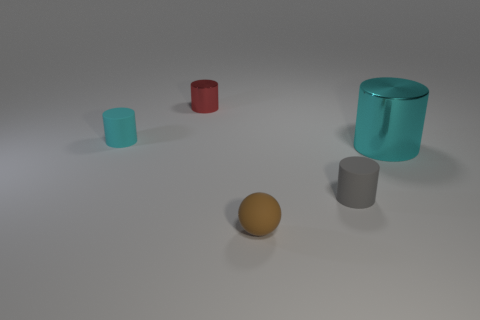There is a small rubber thing that is on the right side of the brown matte thing; what is its shape?
Keep it short and to the point. Cylinder. Is the brown thing made of the same material as the cyan object on the left side of the gray rubber cylinder?
Offer a very short reply. Yes. Are there any big gray rubber balls?
Give a very brief answer. No. Is there a tiny ball that is behind the metallic cylinder that is left of the metallic cylinder that is right of the tiny red metal cylinder?
Make the answer very short. No. How many big objects are gray matte cylinders or spheres?
Your answer should be very brief. 0. What color is the sphere that is the same size as the red cylinder?
Offer a terse response. Brown. There is a tiny shiny cylinder; how many small cyan things are on the right side of it?
Offer a terse response. 0. Is there a large yellow block that has the same material as the red thing?
Your response must be concise. No. The tiny rubber cylinder that is to the right of the small brown rubber object is what color?
Make the answer very short. Gray. Are there the same number of big cyan metal cylinders behind the cyan rubber thing and small brown things to the left of the small brown ball?
Your response must be concise. Yes. 